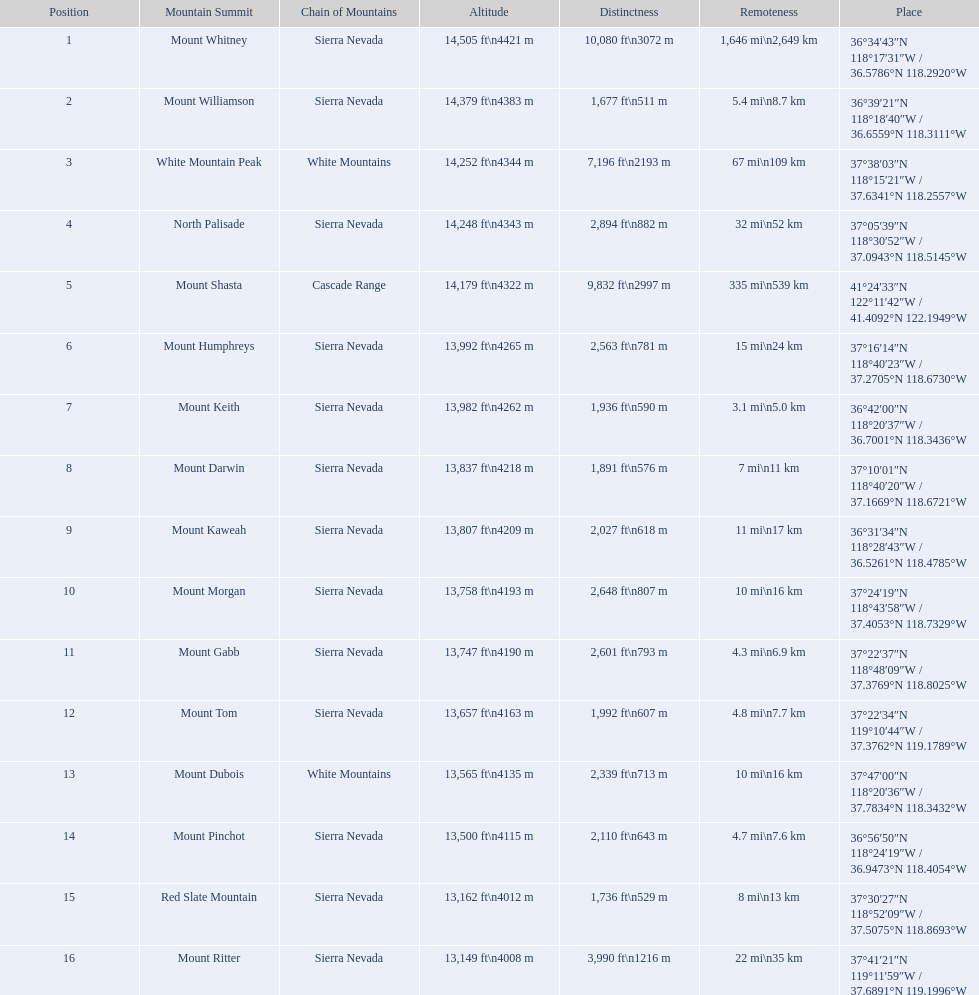What mountain peak is listed for the sierra nevada mountain range? Mount Whitney. What mountain peak has an elevation of 14,379ft? Mount Williamson. Which mountain is listed for the cascade range? Mount Shasta. 